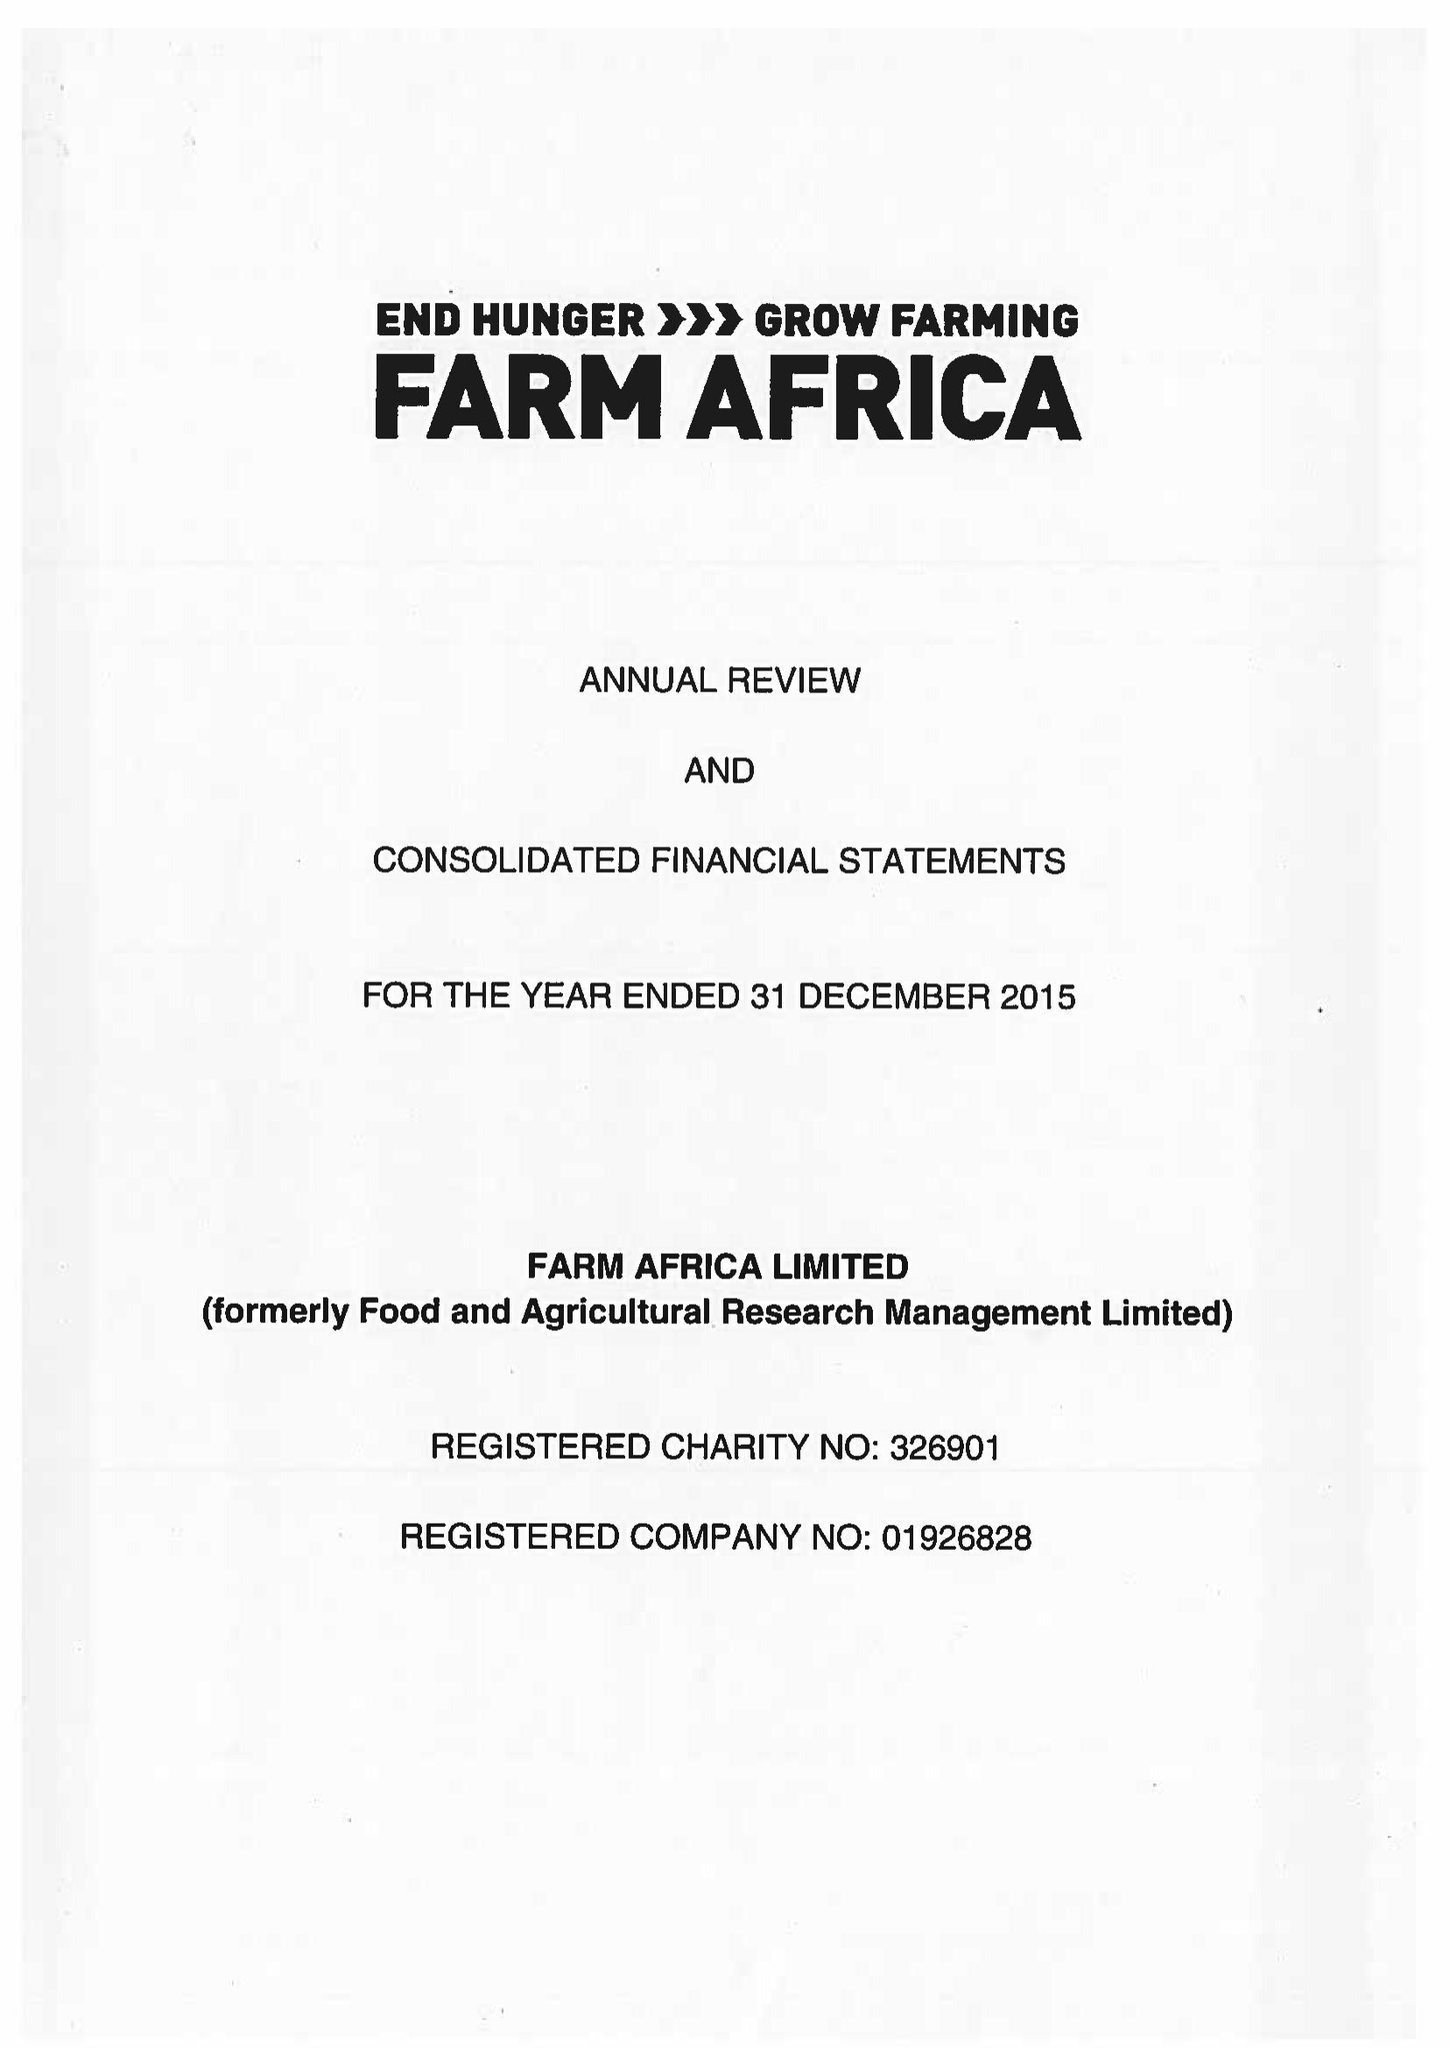What is the value for the address__street_line?
Answer the question using a single word or phrase. 140 LONDON WALL 